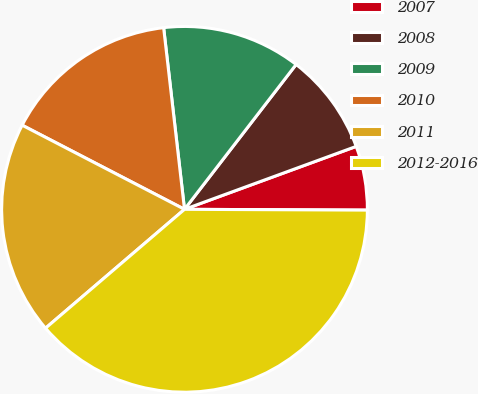Convert chart. <chart><loc_0><loc_0><loc_500><loc_500><pie_chart><fcel>2007<fcel>2008<fcel>2009<fcel>2010<fcel>2011<fcel>2012-2016<nl><fcel>5.66%<fcel>8.96%<fcel>12.27%<fcel>15.57%<fcel>18.87%<fcel>38.67%<nl></chart> 